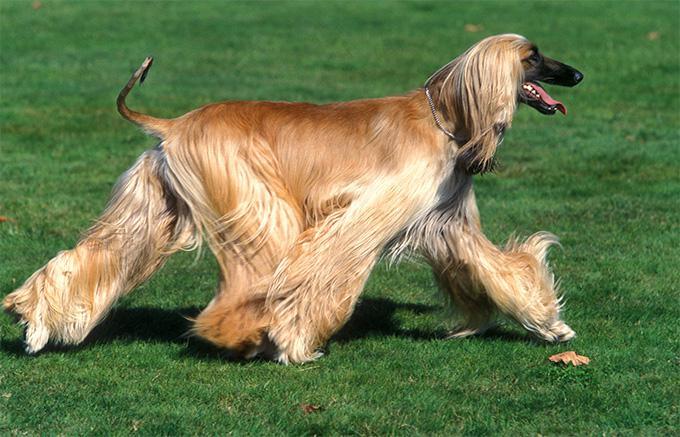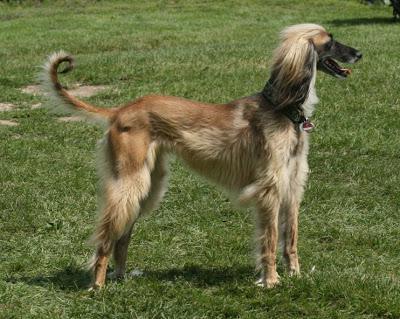The first image is the image on the left, the second image is the image on the right. Assess this claim about the two images: "The dog in the image on the right is turned toward the right.". Correct or not? Answer yes or no. Yes. 